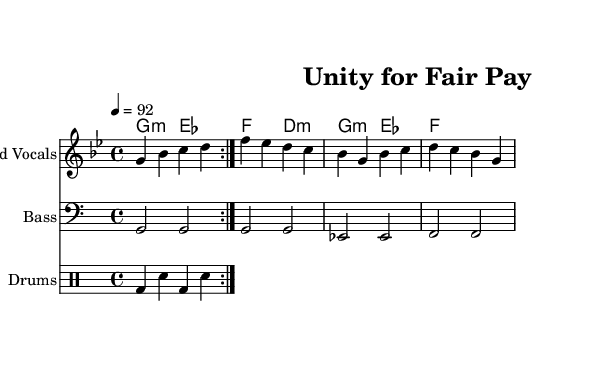what is the key signature of this music? The key signature is G minor, identifiable by the two flats (B flat and E flat) in the key signature at the beginning of the sheet music.
Answer: G minor what is the time signature of this music? The time signature is 4/4, indicated by the fraction displayed at the beginning of the score, which signifies four beats per measure with each beat being a quarter note.
Answer: 4/4 what is the tempo marking for this piece? The tempo marking is 92, indicated by the number above the staff that suggests a beats per minute count, guiding the speed of the performance.
Answer: 92 how many measures are there in the melody part? The melody part consists of 8 measures, as counted by the number of bar lines present in the melody section of the sheet music.
Answer: 8 which chords are used in the progression? The chords used are G minor, E flat major, F major, and D minor, as indicated by the chord symbols written above the staff in the chord names section.
Answer: G minor, E flat major, F major, D minor what rhythm pattern is used in the drums part? The rhythm pattern in the drums part consists of bass drum and snare alternating on every beat within the measures, following the repetition indicated in the drum part.
Answer: Bass and snare what is the theme of the lyrics likely to address based on the title? The theme of the lyrics is likely to address workers' rights and fair labor practices, as the title "Unity for Fair Pay" suggests a focus on economic justice and solidarity among workers.
Answer: Workers' rights and fair labor practices 